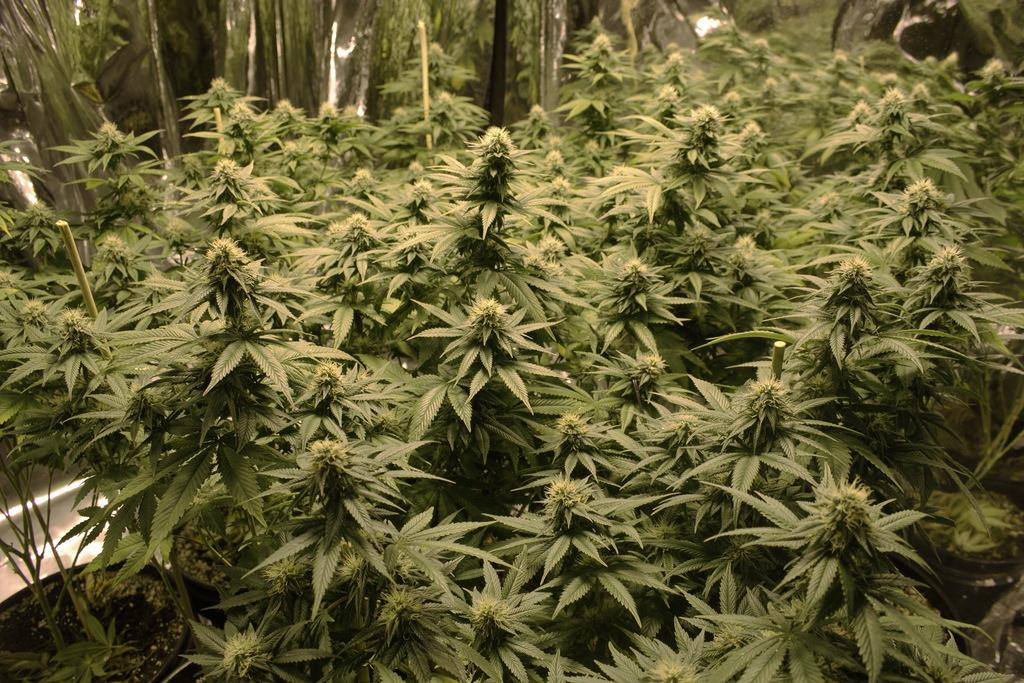What type of vegetation can be seen in the image? There are plants and trees in the image. Can you describe the plants and trees in the image? The image shows plants and trees, but specific details about their appearance cannot be determined from the provided facts. What type of voice can be heard coming from the trees in the image? There is no sound or voice present in the image, as it only features plants and trees. 